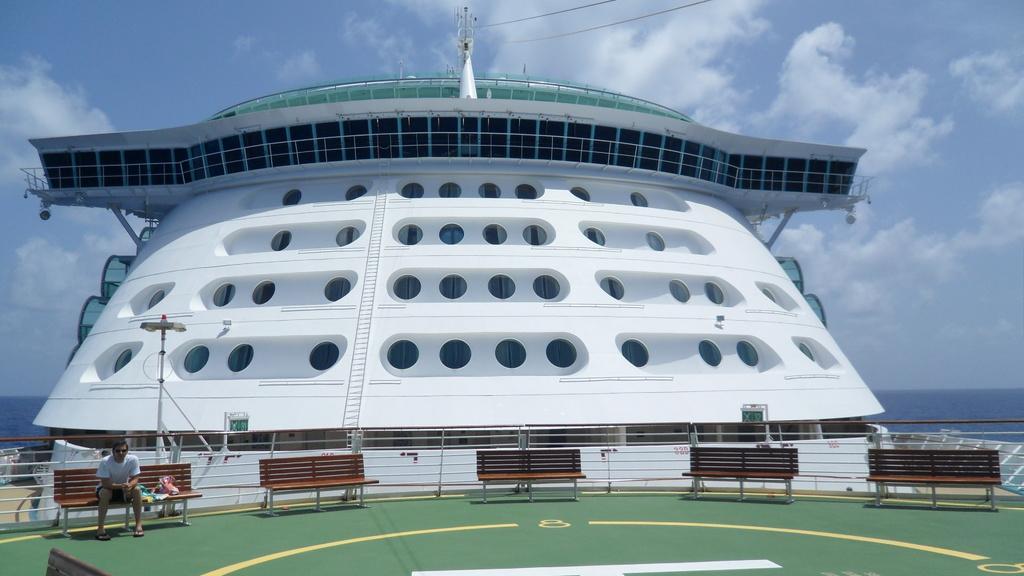How would you summarize this image in a sentence or two? In the image we can see there is a person sitting on the bench and there are benches. There is a cruise standing on the water and there are holes on the building of the cruz. There is a cloudy sky. 